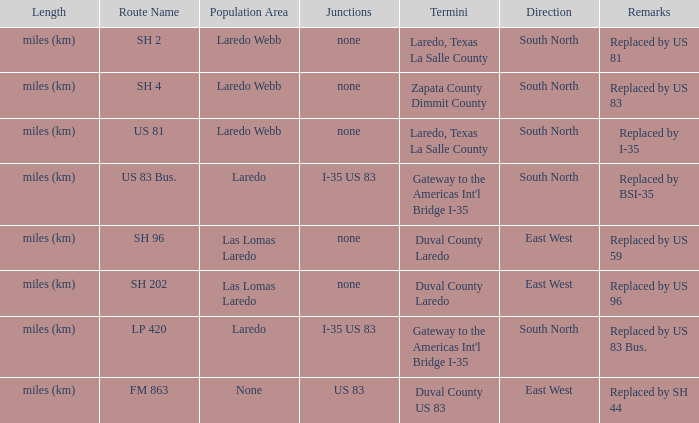How many junctions have "replaced by bsi-35" listed in their remarks section? 1.0. 